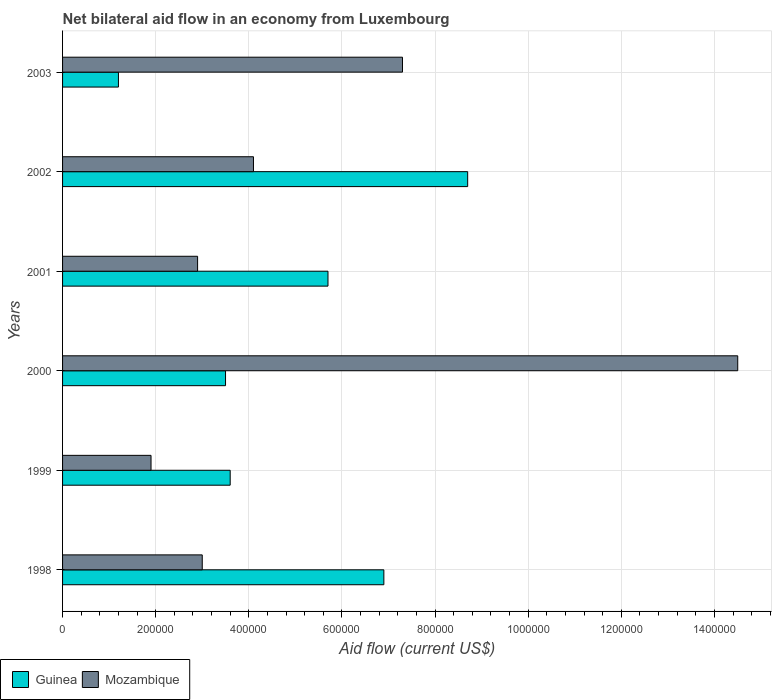How many different coloured bars are there?
Offer a terse response. 2. How many groups of bars are there?
Ensure brevity in your answer.  6. Are the number of bars per tick equal to the number of legend labels?
Provide a succinct answer. Yes. Are the number of bars on each tick of the Y-axis equal?
Your response must be concise. Yes. How many bars are there on the 6th tick from the bottom?
Provide a short and direct response. 2. What is the label of the 2nd group of bars from the top?
Your answer should be very brief. 2002. Across all years, what is the maximum net bilateral aid flow in Mozambique?
Offer a terse response. 1.45e+06. What is the total net bilateral aid flow in Guinea in the graph?
Your answer should be compact. 2.96e+06. What is the difference between the net bilateral aid flow in Mozambique in 2000 and the net bilateral aid flow in Guinea in 2001?
Provide a succinct answer. 8.80e+05. What is the average net bilateral aid flow in Mozambique per year?
Give a very brief answer. 5.62e+05. In the year 2001, what is the difference between the net bilateral aid flow in Mozambique and net bilateral aid flow in Guinea?
Give a very brief answer. -2.80e+05. In how many years, is the net bilateral aid flow in Guinea greater than 1080000 US$?
Your answer should be compact. 0. What is the ratio of the net bilateral aid flow in Mozambique in 1998 to that in 2000?
Provide a succinct answer. 0.21. Is the net bilateral aid flow in Mozambique in 2000 less than that in 2003?
Your answer should be compact. No. Is the difference between the net bilateral aid flow in Mozambique in 2001 and 2002 greater than the difference between the net bilateral aid flow in Guinea in 2001 and 2002?
Your answer should be compact. Yes. What is the difference between the highest and the second highest net bilateral aid flow in Mozambique?
Your answer should be compact. 7.20e+05. What is the difference between the highest and the lowest net bilateral aid flow in Guinea?
Your answer should be very brief. 7.50e+05. In how many years, is the net bilateral aid flow in Guinea greater than the average net bilateral aid flow in Guinea taken over all years?
Your response must be concise. 3. What does the 2nd bar from the top in 1998 represents?
Offer a very short reply. Guinea. What does the 1st bar from the bottom in 2000 represents?
Your answer should be compact. Guinea. How many bars are there?
Provide a short and direct response. 12. Are all the bars in the graph horizontal?
Offer a terse response. Yes. Are the values on the major ticks of X-axis written in scientific E-notation?
Your answer should be very brief. No. Does the graph contain grids?
Offer a terse response. Yes. Where does the legend appear in the graph?
Ensure brevity in your answer.  Bottom left. What is the title of the graph?
Offer a very short reply. Net bilateral aid flow in an economy from Luxembourg. What is the label or title of the X-axis?
Provide a succinct answer. Aid flow (current US$). What is the Aid flow (current US$) in Guinea in 1998?
Provide a succinct answer. 6.90e+05. What is the Aid flow (current US$) in Mozambique in 1998?
Ensure brevity in your answer.  3.00e+05. What is the Aid flow (current US$) of Mozambique in 2000?
Give a very brief answer. 1.45e+06. What is the Aid flow (current US$) of Guinea in 2001?
Your response must be concise. 5.70e+05. What is the Aid flow (current US$) of Mozambique in 2001?
Provide a short and direct response. 2.90e+05. What is the Aid flow (current US$) of Guinea in 2002?
Keep it short and to the point. 8.70e+05. What is the Aid flow (current US$) in Mozambique in 2002?
Ensure brevity in your answer.  4.10e+05. What is the Aid flow (current US$) in Guinea in 2003?
Your response must be concise. 1.20e+05. What is the Aid flow (current US$) in Mozambique in 2003?
Your answer should be very brief. 7.30e+05. Across all years, what is the maximum Aid flow (current US$) in Guinea?
Keep it short and to the point. 8.70e+05. Across all years, what is the maximum Aid flow (current US$) in Mozambique?
Your answer should be very brief. 1.45e+06. Across all years, what is the minimum Aid flow (current US$) of Guinea?
Your answer should be compact. 1.20e+05. Across all years, what is the minimum Aid flow (current US$) of Mozambique?
Offer a terse response. 1.90e+05. What is the total Aid flow (current US$) in Guinea in the graph?
Your answer should be compact. 2.96e+06. What is the total Aid flow (current US$) in Mozambique in the graph?
Your answer should be compact. 3.37e+06. What is the difference between the Aid flow (current US$) of Guinea in 1998 and that in 2000?
Your response must be concise. 3.40e+05. What is the difference between the Aid flow (current US$) in Mozambique in 1998 and that in 2000?
Give a very brief answer. -1.15e+06. What is the difference between the Aid flow (current US$) of Guinea in 1998 and that in 2001?
Your answer should be compact. 1.20e+05. What is the difference between the Aid flow (current US$) of Guinea in 1998 and that in 2002?
Offer a very short reply. -1.80e+05. What is the difference between the Aid flow (current US$) in Mozambique in 1998 and that in 2002?
Offer a very short reply. -1.10e+05. What is the difference between the Aid flow (current US$) in Guinea in 1998 and that in 2003?
Make the answer very short. 5.70e+05. What is the difference between the Aid flow (current US$) of Mozambique in 1998 and that in 2003?
Keep it short and to the point. -4.30e+05. What is the difference between the Aid flow (current US$) of Guinea in 1999 and that in 2000?
Provide a succinct answer. 10000. What is the difference between the Aid flow (current US$) of Mozambique in 1999 and that in 2000?
Give a very brief answer. -1.26e+06. What is the difference between the Aid flow (current US$) in Guinea in 1999 and that in 2002?
Your answer should be very brief. -5.10e+05. What is the difference between the Aid flow (current US$) in Mozambique in 1999 and that in 2002?
Your answer should be very brief. -2.20e+05. What is the difference between the Aid flow (current US$) of Guinea in 1999 and that in 2003?
Provide a succinct answer. 2.40e+05. What is the difference between the Aid flow (current US$) in Mozambique in 1999 and that in 2003?
Offer a very short reply. -5.40e+05. What is the difference between the Aid flow (current US$) of Guinea in 2000 and that in 2001?
Your answer should be compact. -2.20e+05. What is the difference between the Aid flow (current US$) in Mozambique in 2000 and that in 2001?
Provide a short and direct response. 1.16e+06. What is the difference between the Aid flow (current US$) in Guinea in 2000 and that in 2002?
Give a very brief answer. -5.20e+05. What is the difference between the Aid flow (current US$) of Mozambique in 2000 and that in 2002?
Provide a short and direct response. 1.04e+06. What is the difference between the Aid flow (current US$) of Guinea in 2000 and that in 2003?
Your answer should be very brief. 2.30e+05. What is the difference between the Aid flow (current US$) in Mozambique in 2000 and that in 2003?
Offer a very short reply. 7.20e+05. What is the difference between the Aid flow (current US$) of Guinea in 2001 and that in 2002?
Give a very brief answer. -3.00e+05. What is the difference between the Aid flow (current US$) in Mozambique in 2001 and that in 2002?
Keep it short and to the point. -1.20e+05. What is the difference between the Aid flow (current US$) of Guinea in 2001 and that in 2003?
Offer a very short reply. 4.50e+05. What is the difference between the Aid flow (current US$) in Mozambique in 2001 and that in 2003?
Offer a very short reply. -4.40e+05. What is the difference between the Aid flow (current US$) in Guinea in 2002 and that in 2003?
Offer a terse response. 7.50e+05. What is the difference between the Aid flow (current US$) in Mozambique in 2002 and that in 2003?
Keep it short and to the point. -3.20e+05. What is the difference between the Aid flow (current US$) of Guinea in 1998 and the Aid flow (current US$) of Mozambique in 2000?
Make the answer very short. -7.60e+05. What is the difference between the Aid flow (current US$) in Guinea in 1998 and the Aid flow (current US$) in Mozambique in 2001?
Give a very brief answer. 4.00e+05. What is the difference between the Aid flow (current US$) in Guinea in 1998 and the Aid flow (current US$) in Mozambique in 2003?
Provide a succinct answer. -4.00e+04. What is the difference between the Aid flow (current US$) of Guinea in 1999 and the Aid flow (current US$) of Mozambique in 2000?
Your answer should be compact. -1.09e+06. What is the difference between the Aid flow (current US$) of Guinea in 1999 and the Aid flow (current US$) of Mozambique in 2003?
Your answer should be very brief. -3.70e+05. What is the difference between the Aid flow (current US$) of Guinea in 2000 and the Aid flow (current US$) of Mozambique in 2003?
Offer a very short reply. -3.80e+05. What is the difference between the Aid flow (current US$) of Guinea in 2001 and the Aid flow (current US$) of Mozambique in 2002?
Offer a terse response. 1.60e+05. What is the difference between the Aid flow (current US$) of Guinea in 2001 and the Aid flow (current US$) of Mozambique in 2003?
Provide a succinct answer. -1.60e+05. What is the difference between the Aid flow (current US$) in Guinea in 2002 and the Aid flow (current US$) in Mozambique in 2003?
Your response must be concise. 1.40e+05. What is the average Aid flow (current US$) of Guinea per year?
Offer a very short reply. 4.93e+05. What is the average Aid flow (current US$) of Mozambique per year?
Your answer should be very brief. 5.62e+05. In the year 1998, what is the difference between the Aid flow (current US$) of Guinea and Aid flow (current US$) of Mozambique?
Your response must be concise. 3.90e+05. In the year 1999, what is the difference between the Aid flow (current US$) of Guinea and Aid flow (current US$) of Mozambique?
Keep it short and to the point. 1.70e+05. In the year 2000, what is the difference between the Aid flow (current US$) in Guinea and Aid flow (current US$) in Mozambique?
Provide a short and direct response. -1.10e+06. In the year 2001, what is the difference between the Aid flow (current US$) of Guinea and Aid flow (current US$) of Mozambique?
Your response must be concise. 2.80e+05. In the year 2003, what is the difference between the Aid flow (current US$) in Guinea and Aid flow (current US$) in Mozambique?
Make the answer very short. -6.10e+05. What is the ratio of the Aid flow (current US$) in Guinea in 1998 to that in 1999?
Your answer should be very brief. 1.92. What is the ratio of the Aid flow (current US$) in Mozambique in 1998 to that in 1999?
Keep it short and to the point. 1.58. What is the ratio of the Aid flow (current US$) of Guinea in 1998 to that in 2000?
Offer a terse response. 1.97. What is the ratio of the Aid flow (current US$) of Mozambique in 1998 to that in 2000?
Give a very brief answer. 0.21. What is the ratio of the Aid flow (current US$) in Guinea in 1998 to that in 2001?
Provide a short and direct response. 1.21. What is the ratio of the Aid flow (current US$) of Mozambique in 1998 to that in 2001?
Provide a succinct answer. 1.03. What is the ratio of the Aid flow (current US$) of Guinea in 1998 to that in 2002?
Keep it short and to the point. 0.79. What is the ratio of the Aid flow (current US$) of Mozambique in 1998 to that in 2002?
Your answer should be compact. 0.73. What is the ratio of the Aid flow (current US$) of Guinea in 1998 to that in 2003?
Provide a succinct answer. 5.75. What is the ratio of the Aid flow (current US$) in Mozambique in 1998 to that in 2003?
Your answer should be very brief. 0.41. What is the ratio of the Aid flow (current US$) of Guinea in 1999 to that in 2000?
Your answer should be compact. 1.03. What is the ratio of the Aid flow (current US$) in Mozambique in 1999 to that in 2000?
Your answer should be compact. 0.13. What is the ratio of the Aid flow (current US$) of Guinea in 1999 to that in 2001?
Provide a succinct answer. 0.63. What is the ratio of the Aid flow (current US$) of Mozambique in 1999 to that in 2001?
Your response must be concise. 0.66. What is the ratio of the Aid flow (current US$) in Guinea in 1999 to that in 2002?
Give a very brief answer. 0.41. What is the ratio of the Aid flow (current US$) of Mozambique in 1999 to that in 2002?
Make the answer very short. 0.46. What is the ratio of the Aid flow (current US$) of Mozambique in 1999 to that in 2003?
Your answer should be compact. 0.26. What is the ratio of the Aid flow (current US$) of Guinea in 2000 to that in 2001?
Give a very brief answer. 0.61. What is the ratio of the Aid flow (current US$) of Mozambique in 2000 to that in 2001?
Offer a terse response. 5. What is the ratio of the Aid flow (current US$) of Guinea in 2000 to that in 2002?
Give a very brief answer. 0.4. What is the ratio of the Aid flow (current US$) of Mozambique in 2000 to that in 2002?
Give a very brief answer. 3.54. What is the ratio of the Aid flow (current US$) of Guinea in 2000 to that in 2003?
Ensure brevity in your answer.  2.92. What is the ratio of the Aid flow (current US$) in Mozambique in 2000 to that in 2003?
Provide a succinct answer. 1.99. What is the ratio of the Aid flow (current US$) in Guinea in 2001 to that in 2002?
Your answer should be compact. 0.66. What is the ratio of the Aid flow (current US$) of Mozambique in 2001 to that in 2002?
Offer a very short reply. 0.71. What is the ratio of the Aid flow (current US$) in Guinea in 2001 to that in 2003?
Your response must be concise. 4.75. What is the ratio of the Aid flow (current US$) of Mozambique in 2001 to that in 2003?
Make the answer very short. 0.4. What is the ratio of the Aid flow (current US$) of Guinea in 2002 to that in 2003?
Provide a succinct answer. 7.25. What is the ratio of the Aid flow (current US$) in Mozambique in 2002 to that in 2003?
Your answer should be compact. 0.56. What is the difference between the highest and the second highest Aid flow (current US$) of Mozambique?
Ensure brevity in your answer.  7.20e+05. What is the difference between the highest and the lowest Aid flow (current US$) in Guinea?
Offer a very short reply. 7.50e+05. What is the difference between the highest and the lowest Aid flow (current US$) of Mozambique?
Make the answer very short. 1.26e+06. 